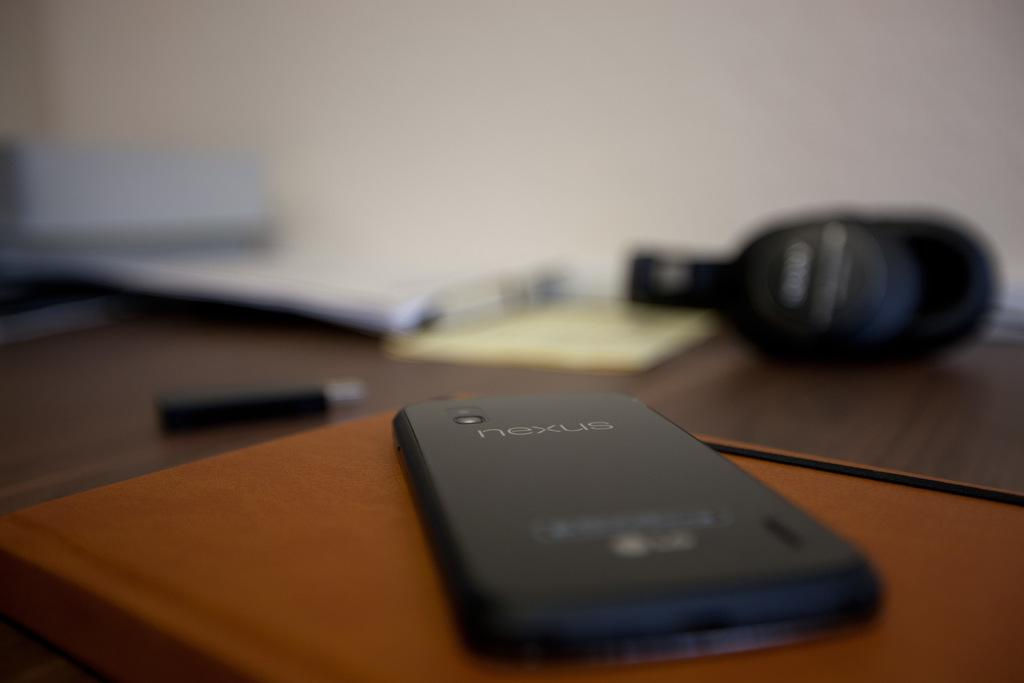<image>
Give a short and clear explanation of the subsequent image. A Nexus branded cell phon sitting face down on top of a brown book. 